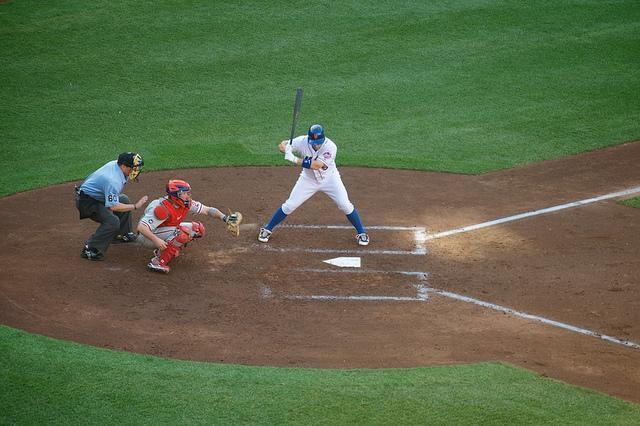How many people are there?
Give a very brief answer. 3. How many blue ties are there?
Give a very brief answer. 0. 